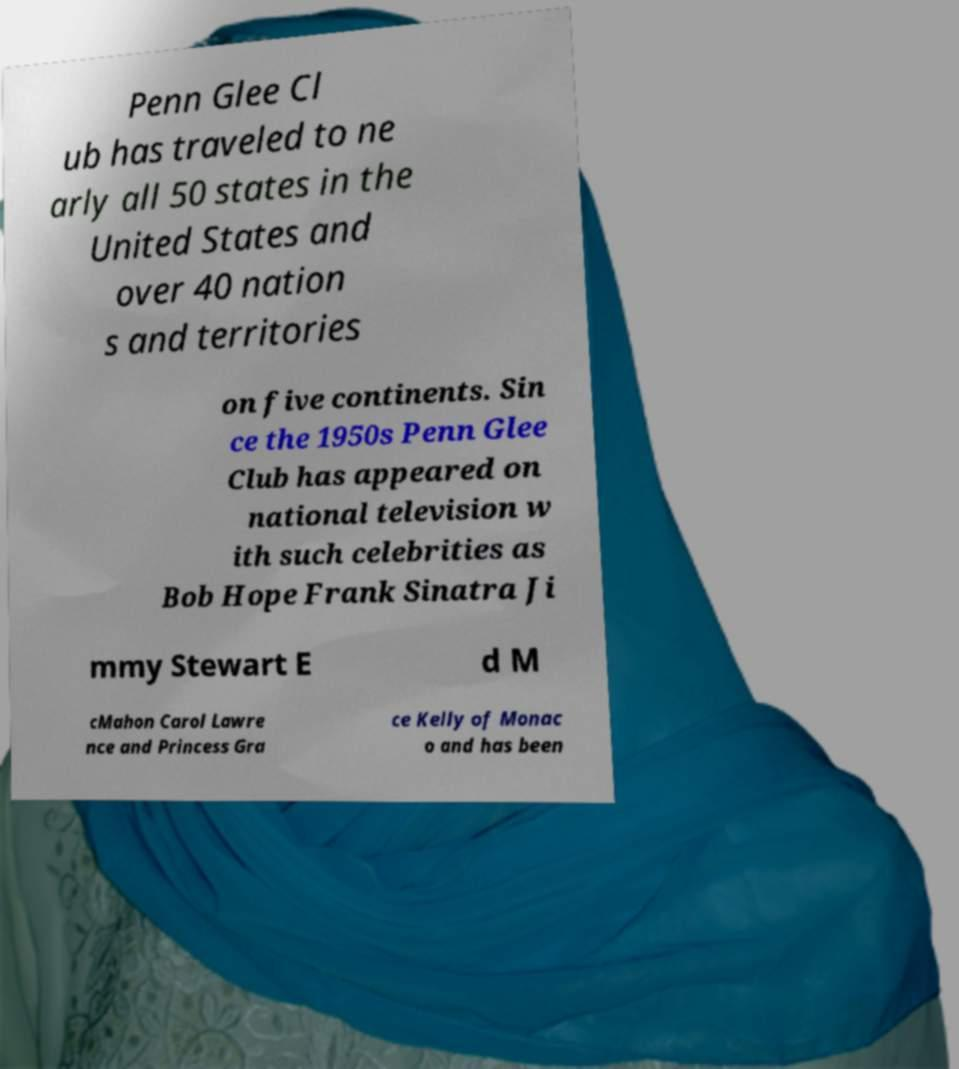I need the written content from this picture converted into text. Can you do that? Penn Glee Cl ub has traveled to ne arly all 50 states in the United States and over 40 nation s and territories on five continents. Sin ce the 1950s Penn Glee Club has appeared on national television w ith such celebrities as Bob Hope Frank Sinatra Ji mmy Stewart E d M cMahon Carol Lawre nce and Princess Gra ce Kelly of Monac o and has been 